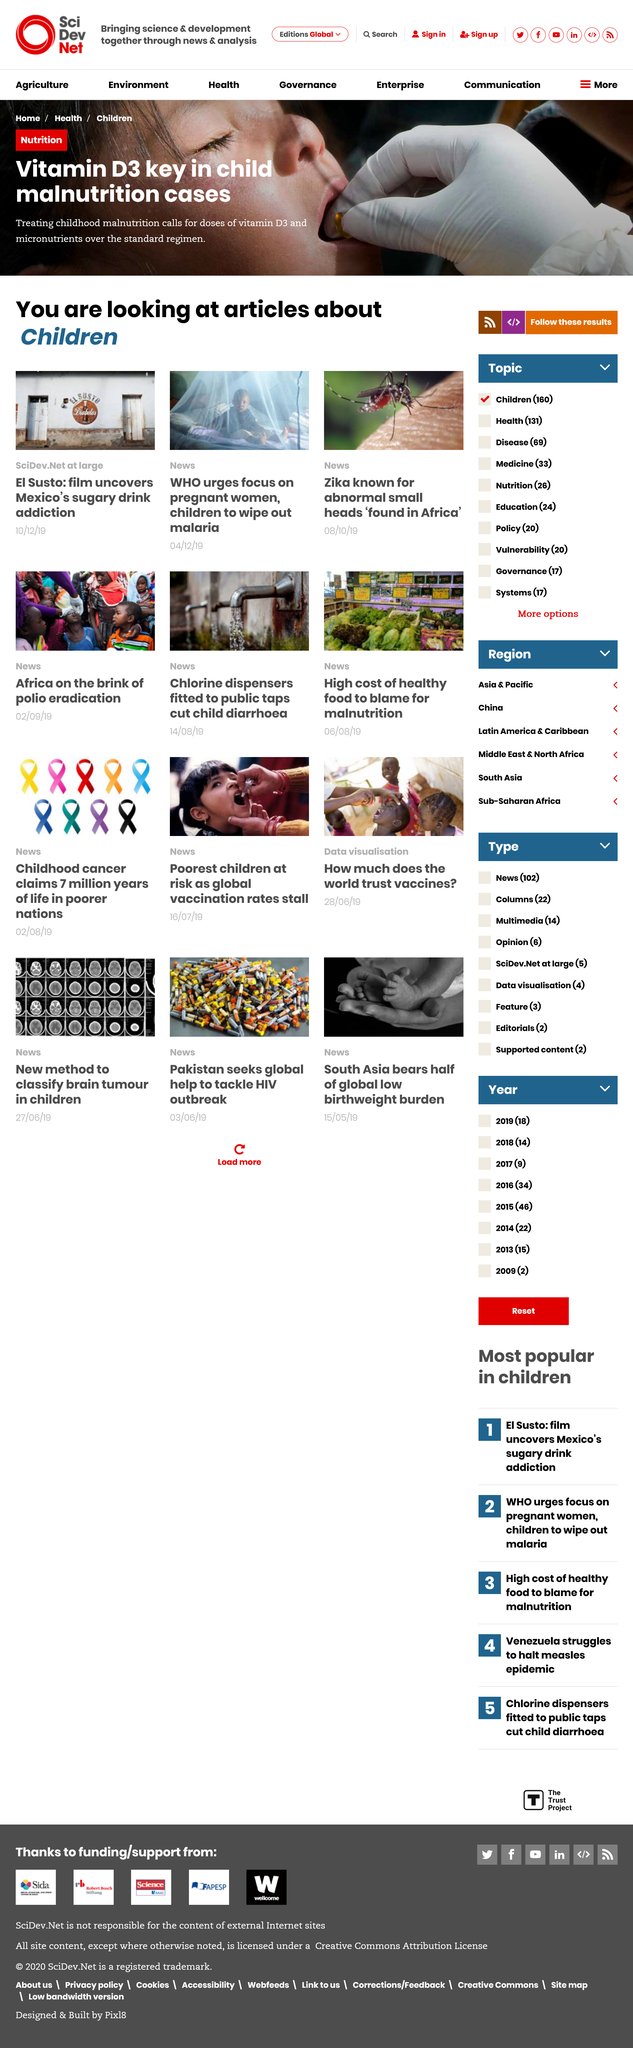Give some essential details in this illustration. The article titled 'El Susto: film uncovers Mexico's sugary drink addiction' was published on October 12th, 2019. Vitamin D3 is considered essential in the treatment of child malnutrition cases. The World Health Organization (WHO) urges the focus on pregnant women and children to eradicate malaria. 